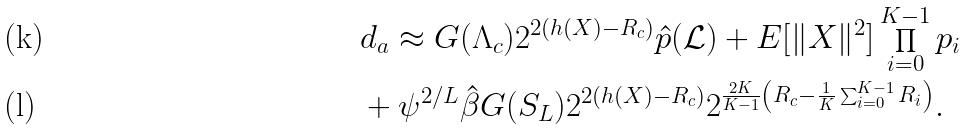<formula> <loc_0><loc_0><loc_500><loc_500>& d _ { a } \approx G ( \Lambda _ { c } ) 2 ^ { 2 ( h ( X ) - R _ { c } ) } \hat { p } ( \mathcal { L } ) + E [ \| X \| ^ { 2 } ] \prod _ { i = 0 } ^ { K - 1 } p _ { i } \\ & + \psi ^ { 2 / L } \hat { \beta } G ( S _ { L } ) 2 ^ { 2 ( h ( X ) - R _ { c } ) } 2 ^ { \frac { 2 K } { K - 1 } \left ( R _ { c } - \frac { 1 } { K } \sum _ { i = 0 } ^ { K - 1 } R _ { i } \right ) } .</formula> 